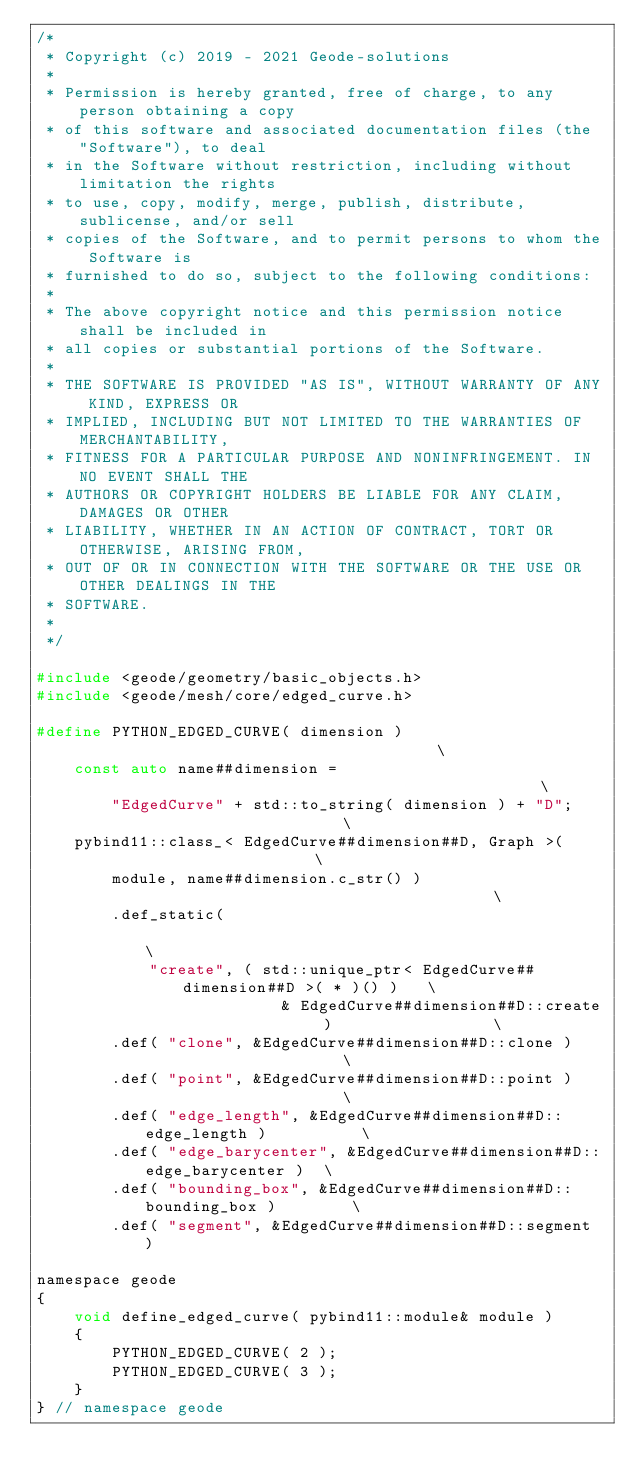<code> <loc_0><loc_0><loc_500><loc_500><_C_>/*
 * Copyright (c) 2019 - 2021 Geode-solutions
 *
 * Permission is hereby granted, free of charge, to any person obtaining a copy
 * of this software and associated documentation files (the "Software"), to deal
 * in the Software without restriction, including without limitation the rights
 * to use, copy, modify, merge, publish, distribute, sublicense, and/or sell
 * copies of the Software, and to permit persons to whom the Software is
 * furnished to do so, subject to the following conditions:
 *
 * The above copyright notice and this permission notice shall be included in
 * all copies or substantial portions of the Software.
 *
 * THE SOFTWARE IS PROVIDED "AS IS", WITHOUT WARRANTY OF ANY KIND, EXPRESS OR
 * IMPLIED, INCLUDING BUT NOT LIMITED TO THE WARRANTIES OF MERCHANTABILITY,
 * FITNESS FOR A PARTICULAR PURPOSE AND NONINFRINGEMENT. IN NO EVENT SHALL THE
 * AUTHORS OR COPYRIGHT HOLDERS BE LIABLE FOR ANY CLAIM, DAMAGES OR OTHER
 * LIABILITY, WHETHER IN AN ACTION OF CONTRACT, TORT OR OTHERWISE, ARISING FROM,
 * OUT OF OR IN CONNECTION WITH THE SOFTWARE OR THE USE OR OTHER DEALINGS IN THE
 * SOFTWARE.
 *
 */

#include <geode/geometry/basic_objects.h>
#include <geode/mesh/core/edged_curve.h>

#define PYTHON_EDGED_CURVE( dimension )                                        \
    const auto name##dimension =                                               \
        "EdgedCurve" + std::to_string( dimension ) + "D";                      \
    pybind11::class_< EdgedCurve##dimension##D, Graph >(                       \
        module, name##dimension.c_str() )                                      \
        .def_static(                                                           \
            "create", ( std::unique_ptr< EdgedCurve##dimension##D >( * )() )   \
                          & EdgedCurve##dimension##D::create )                 \
        .def( "clone", &EdgedCurve##dimension##D::clone )                      \
        .def( "point", &EdgedCurve##dimension##D::point )                      \
        .def( "edge_length", &EdgedCurve##dimension##D::edge_length )          \
        .def( "edge_barycenter", &EdgedCurve##dimension##D::edge_barycenter )  \
        .def( "bounding_box", &EdgedCurve##dimension##D::bounding_box )        \
        .def( "segment", &EdgedCurve##dimension##D::segment )

namespace geode
{
    void define_edged_curve( pybind11::module& module )
    {
        PYTHON_EDGED_CURVE( 2 );
        PYTHON_EDGED_CURVE( 3 );
    }
} // namespace geode
</code> 